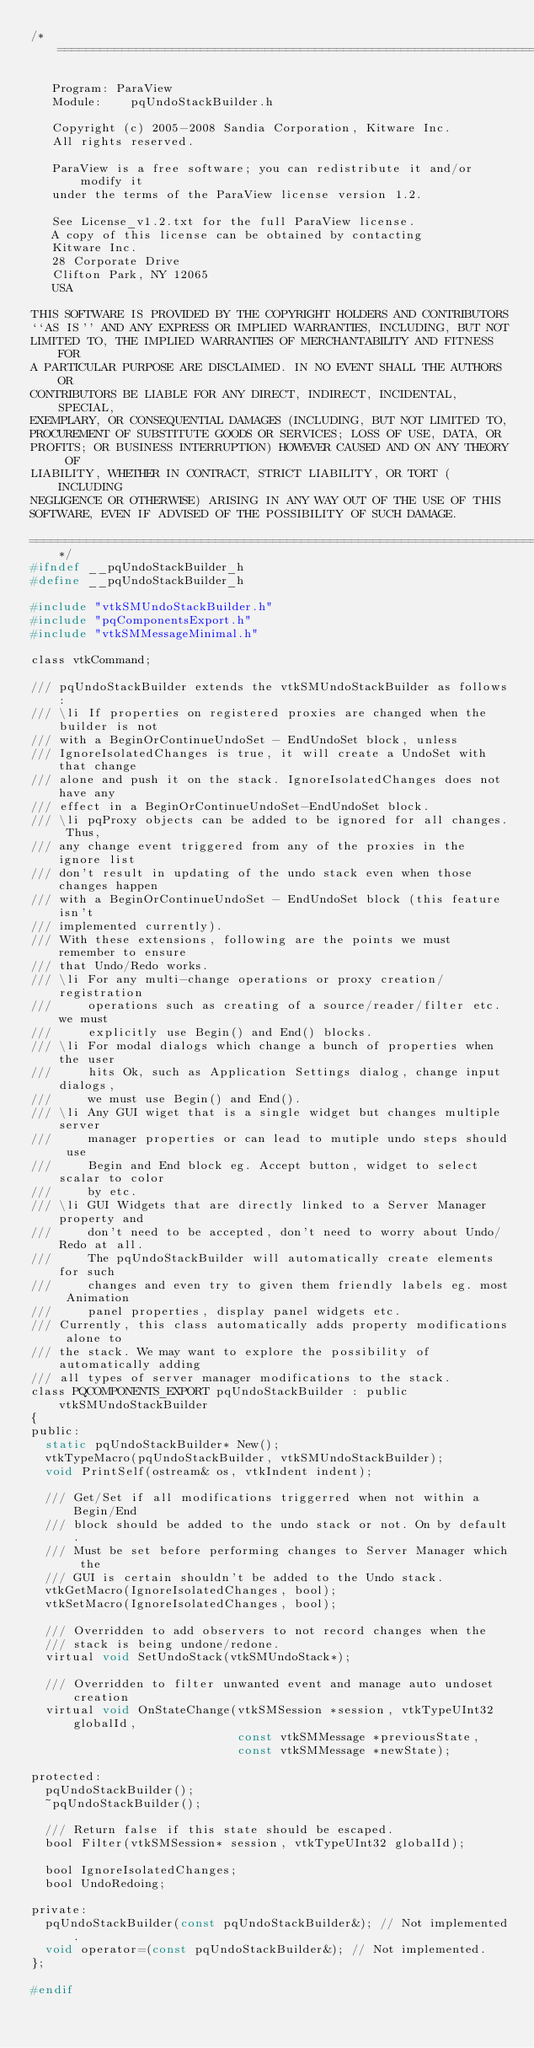<code> <loc_0><loc_0><loc_500><loc_500><_C_>/*=========================================================================

   Program: ParaView
   Module:    pqUndoStackBuilder.h

   Copyright (c) 2005-2008 Sandia Corporation, Kitware Inc.
   All rights reserved.

   ParaView is a free software; you can redistribute it and/or modify it
   under the terms of the ParaView license version 1.2. 

   See License_v1.2.txt for the full ParaView license.
   A copy of this license can be obtained by contacting
   Kitware Inc.
   28 Corporate Drive
   Clifton Park, NY 12065
   USA

THIS SOFTWARE IS PROVIDED BY THE COPYRIGHT HOLDERS AND CONTRIBUTORS
``AS IS'' AND ANY EXPRESS OR IMPLIED WARRANTIES, INCLUDING, BUT NOT
LIMITED TO, THE IMPLIED WARRANTIES OF MERCHANTABILITY AND FITNESS FOR
A PARTICULAR PURPOSE ARE DISCLAIMED. IN NO EVENT SHALL THE AUTHORS OR
CONTRIBUTORS BE LIABLE FOR ANY DIRECT, INDIRECT, INCIDENTAL, SPECIAL,
EXEMPLARY, OR CONSEQUENTIAL DAMAGES (INCLUDING, BUT NOT LIMITED TO,
PROCUREMENT OF SUBSTITUTE GOODS OR SERVICES; LOSS OF USE, DATA, OR
PROFITS; OR BUSINESS INTERRUPTION) HOWEVER CAUSED AND ON ANY THEORY OF
LIABILITY, WHETHER IN CONTRACT, STRICT LIABILITY, OR TORT (INCLUDING
NEGLIGENCE OR OTHERWISE) ARISING IN ANY WAY OUT OF THE USE OF THIS
SOFTWARE, EVEN IF ADVISED OF THE POSSIBILITY OF SUCH DAMAGE.

=========================================================================*/
#ifndef __pqUndoStackBuilder_h
#define __pqUndoStackBuilder_h

#include "vtkSMUndoStackBuilder.h"
#include "pqComponentsExport.h"
#include "vtkSMMessageMinimal.h"

class vtkCommand;

/// pqUndoStackBuilder extends the vtkSMUndoStackBuilder as follows:
/// \li If properties on registered proxies are changed when the builder is not
/// with a BeginOrContinueUndoSet - EndUndoSet block, unless 
/// IgnoreIsolatedChanges is true, it will create a UndoSet with that change 
/// alone and push it on the stack. IgnoreIsolatedChanges does not have any 
/// effect in a BeginOrContinueUndoSet-EndUndoSet block.
/// \li pqProxy objects can be added to be ignored for all changes. Thus,
/// any change event triggered from any of the proxies in the ignore list
/// don't result in updating of the undo stack even when those changes happen
/// with a BeginOrContinueUndoSet - EndUndoSet block (this feature isn't 
/// implemented currently).
/// With these extensions, following are the points we must remember to ensure
/// that Undo/Redo works.
/// \li For any multi-change operations or proxy creation/registration 
///     operations such as creating of a source/reader/filter etc. we must 
///     explicitly use Begin() and End() blocks.
/// \li For modal dialogs which change a bunch of properties when the user 
///     hits Ok, such as Application Settings dialog, change input dialogs, 
///     we must use Begin() and End().
/// \li Any GUI wiget that is a single widget but changes multiple server 
///     manager properties or can lead to mutiple undo steps should use 
///     Begin and End block eg. Accept button, widget to select scalar to color 
///     by etc.
/// \li GUI Widgets that are directly linked to a Server Manager property and 
///     don't need to be accepted, don't need to worry about Undo/Redo at all.
///     The pqUndoStackBuilder will automatically create elements for such 
///     changes and even try to given them friendly labels eg. most Animation 
///     panel properties, display panel widgets etc.
/// Currently, this class automatically adds property modifications alone to 
/// the stack. We may want to explore the possibility of automatically adding 
/// all types of server manager modifications to the stack.
class PQCOMPONENTS_EXPORT pqUndoStackBuilder : public vtkSMUndoStackBuilder
{
public:
  static pqUndoStackBuilder* New();
  vtkTypeMacro(pqUndoStackBuilder, vtkSMUndoStackBuilder);
  void PrintSelf(ostream& os, vtkIndent indent);

  /// Get/Set if all modifications triggerred when not within a Begin/End
  /// block should be added to the undo stack or not. On by default.
  /// Must be set before performing changes to Server Manager which the
  /// GUI is certain shouldn't be added to the Undo stack.
  vtkGetMacro(IgnoreIsolatedChanges, bool);
  vtkSetMacro(IgnoreIsolatedChanges, bool);

  /// Overridden to add observers to not record changes when the
  /// stack is being undone/redone.
  virtual void SetUndoStack(vtkSMUndoStack*);

  /// Overridden to filter unwanted event and manage auto undoset creation
  virtual void OnStateChange(vtkSMSession *session, vtkTypeUInt32 globalId,
                             const vtkSMMessage *previousState,
                             const vtkSMMessage *newState);

protected:
  pqUndoStackBuilder();
  ~pqUndoStackBuilder();

  /// Return false if this state should be escaped.
  bool Filter(vtkSMSession* session, vtkTypeUInt32 globalId);

  bool IgnoreIsolatedChanges;
  bool UndoRedoing;

private:
  pqUndoStackBuilder(const pqUndoStackBuilder&); // Not implemented.
  void operator=(const pqUndoStackBuilder&); // Not implemented.
};

#endif

</code> 